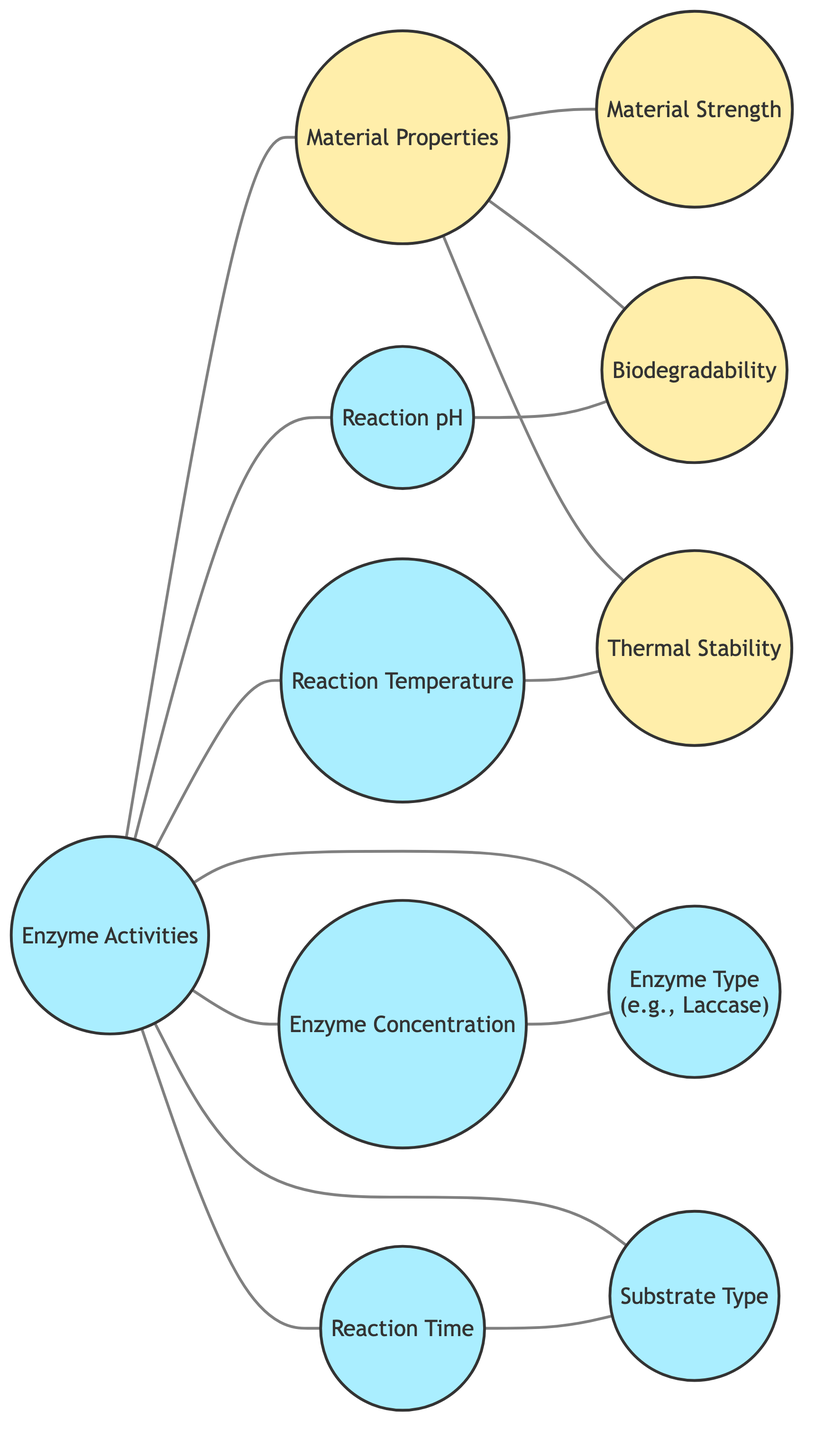What are the total number of nodes in the graph? The graph contains 11 nodes, which are: Enzyme Activities, Material Properties, Enzyme Concentration, Reaction Temperature, Reaction pH, Material Strength, Biodegradability, Enzyme Type, Reaction Time, Substrate Type, and Thermal Stability. Counting each unique label gives a total of 11.
Answer: 11 How many edges connect to Enzyme Activities? The Enzyme Activities node has edges connecting it to Enzyme Concentration, Reaction Temperature, Reaction pH, Enzyme Type, Reaction Time, Substrate Type, and Material Properties. Counting these edges gives a total of 7.
Answer: 7 Which material property is directly connected to Reaction pH? The Reaction pH node has a direct connection to the Biodegradability node. This can be traced directly from the graph where there is an edge between Reaction pH and Biodegradability.
Answer: Biodegradability Is there a direct connection between Reaction Temperature and Material Strength? No, there is no direct edge connecting Reaction Temperature to Material Strength in the graph. This can be confirmed by checking if an edge exists between those two nodes, which it does not.
Answer: No What is the relationship between Enzyme Concentration and Enzyme Type? Enzyme Concentration has a direct connection to Enzyme Type; there is an edge linking these two nodes together in the diagram. Therefore, they are directly related.
Answer: Direct connection How many material properties are influenced by Enzyme Activities? Enzyme Activities influences three material properties, namely Material Strength, Biodegradability, and Thermal Stability. These are directly connected by edges to the Enzyme Activities node.
Answer: Three What is the maximum number of connections associated with Material Properties? Material Properties has 3 edges directly linking it to Material Strength, Biodegradability, and Thermal Stability. Each of these properties is influenced by specific interactions as shown by the edges attached to Material Properties. Thus the maximum count is 3 direct connections.
Answer: 3 Can you list the enzyme-related nodes in the diagram? The enzyme-related nodes in the diagram include Enzyme Activities, Enzyme Concentration, Enzyme Type, which are all marked as enzyme-related in the graph. These nodes are linked to various properties and conditions in the material creation process.
Answer: Enzyme Activities, Enzyme Concentration, Enzyme Type How are Reaction Time and Substrate Type related? Reaction Time and Substrate Type have a direct connection in the graph as indicated by a visible edge that links the two nodes directly. This shows there is an interdependent relationship between them.
Answer: Direct connection 